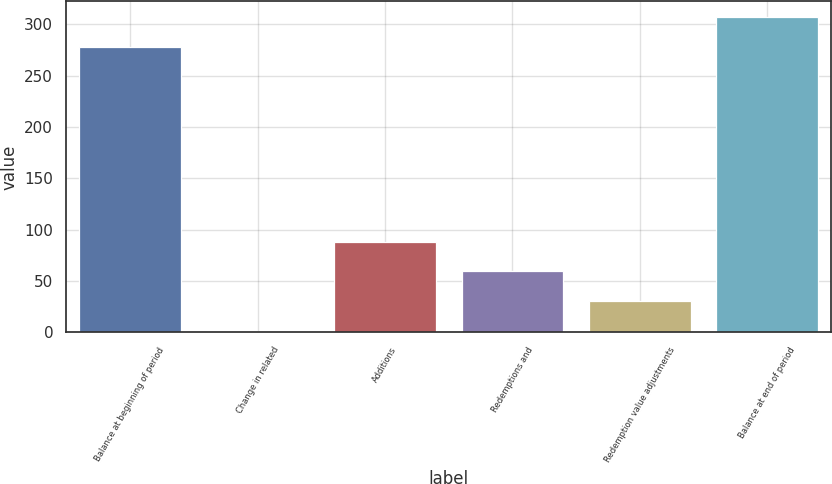Convert chart. <chart><loc_0><loc_0><loc_500><loc_500><bar_chart><fcel>Balance at beginning of period<fcel>Change in related<fcel>Additions<fcel>Redemptions and<fcel>Redemption value adjustments<fcel>Balance at end of period<nl><fcel>277.8<fcel>1.5<fcel>88.41<fcel>59.44<fcel>30.47<fcel>306.77<nl></chart> 